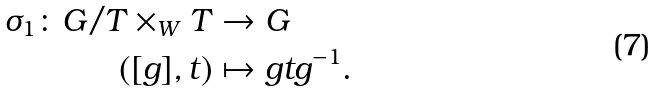<formula> <loc_0><loc_0><loc_500><loc_500>\sigma _ { 1 } \colon G / T \times _ { W } T & \to G \\ ( [ g ] , t ) & \mapsto g t g ^ { - 1 } .</formula> 